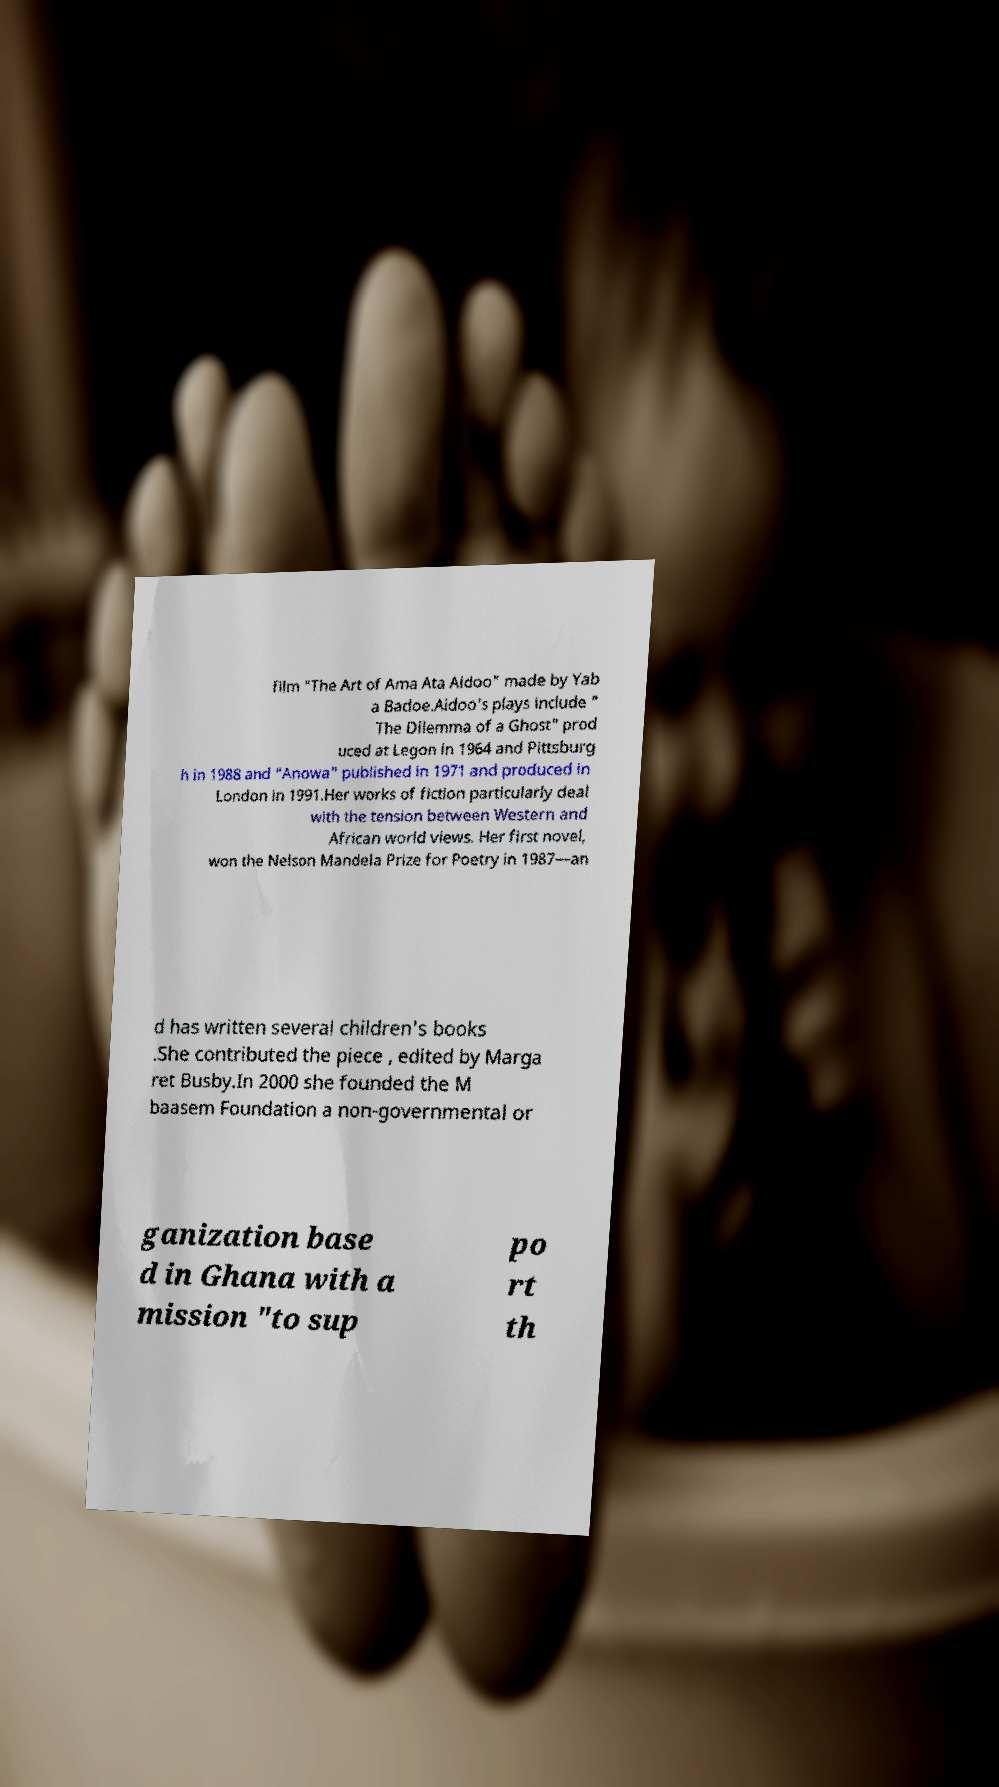Can you accurately transcribe the text from the provided image for me? film "The Art of Ama Ata Aidoo" made by Yab a Badoe.Aidoo's plays include " The Dilemma of a Ghost" prod uced at Legon in 1964 and Pittsburg h in 1988 and "Anowa" published in 1971 and produced in London in 1991.Her works of fiction particularly deal with the tension between Western and African world views. Her first novel, won the Nelson Mandela Prize for Poetry in 1987—an d has written several children's books .She contributed the piece , edited by Marga ret Busby.In 2000 she founded the M baasem Foundation a non-governmental or ganization base d in Ghana with a mission "to sup po rt th 